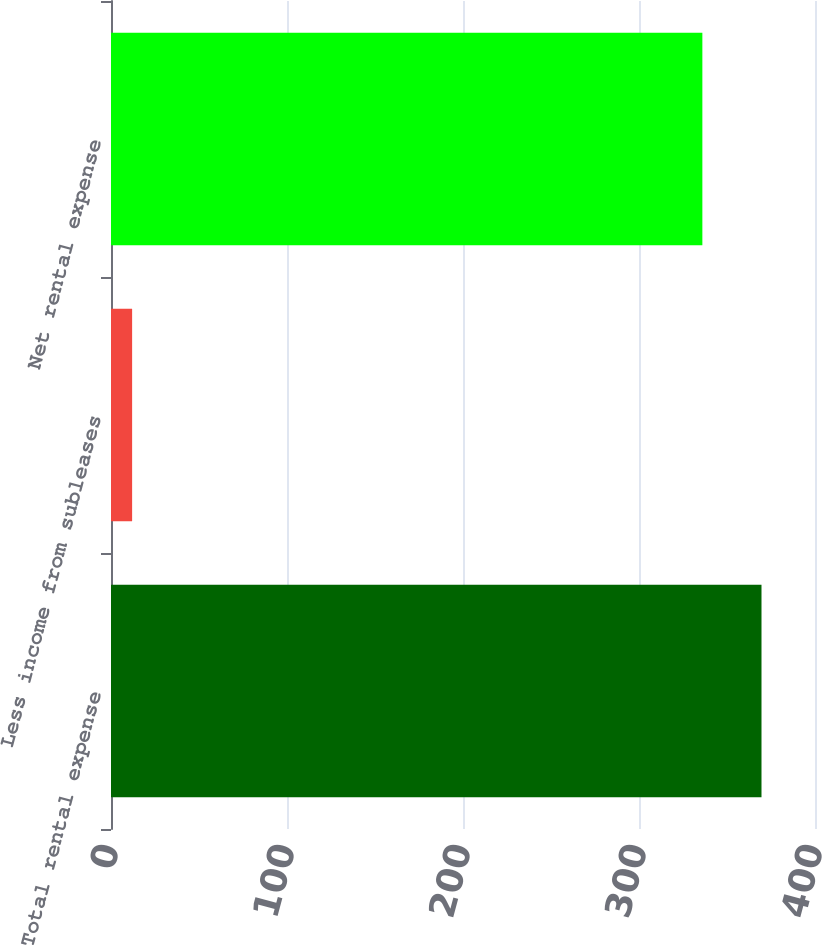Convert chart to OTSL. <chart><loc_0><loc_0><loc_500><loc_500><bar_chart><fcel>Total rental expense<fcel>Less income from subleases<fcel>Net rental expense<nl><fcel>369.6<fcel>12<fcel>336<nl></chart> 